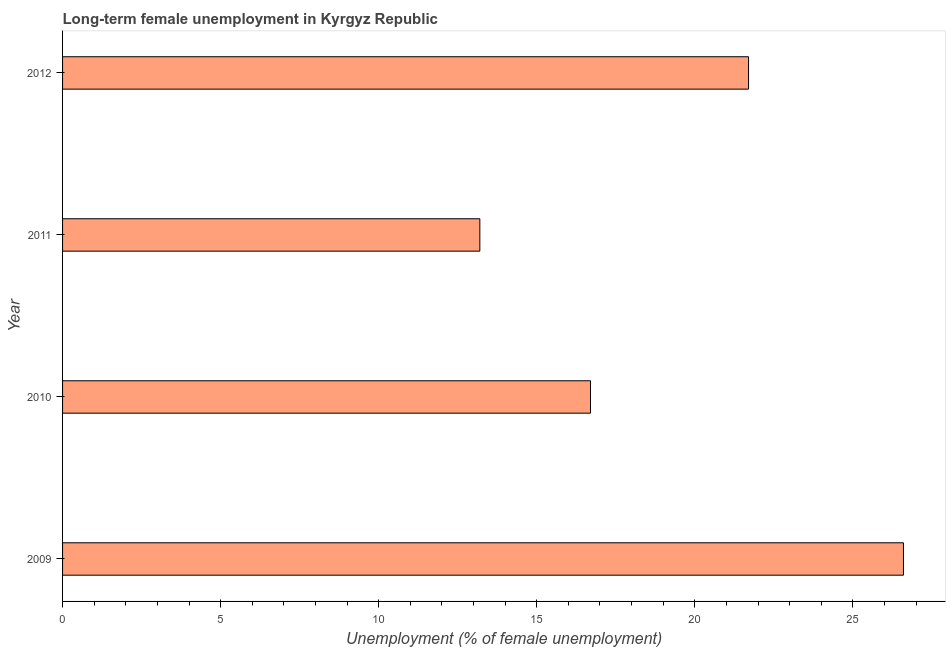Does the graph contain any zero values?
Give a very brief answer. No. What is the title of the graph?
Make the answer very short. Long-term female unemployment in Kyrgyz Republic. What is the label or title of the X-axis?
Make the answer very short. Unemployment (% of female unemployment). What is the long-term female unemployment in 2010?
Make the answer very short. 16.7. Across all years, what is the maximum long-term female unemployment?
Your answer should be very brief. 26.6. Across all years, what is the minimum long-term female unemployment?
Give a very brief answer. 13.2. In which year was the long-term female unemployment maximum?
Offer a very short reply. 2009. In which year was the long-term female unemployment minimum?
Your answer should be very brief. 2011. What is the sum of the long-term female unemployment?
Your answer should be compact. 78.2. What is the difference between the long-term female unemployment in 2009 and 2012?
Offer a terse response. 4.9. What is the average long-term female unemployment per year?
Provide a succinct answer. 19.55. What is the median long-term female unemployment?
Offer a terse response. 19.2. Do a majority of the years between 2010 and 2012 (inclusive) have long-term female unemployment greater than 24 %?
Provide a short and direct response. No. What is the ratio of the long-term female unemployment in 2009 to that in 2010?
Offer a terse response. 1.59. Is the difference between the long-term female unemployment in 2010 and 2012 greater than the difference between any two years?
Make the answer very short. No. What is the Unemployment (% of female unemployment) of 2009?
Offer a terse response. 26.6. What is the Unemployment (% of female unemployment) of 2010?
Your answer should be very brief. 16.7. What is the Unemployment (% of female unemployment) of 2011?
Give a very brief answer. 13.2. What is the Unemployment (% of female unemployment) of 2012?
Offer a very short reply. 21.7. What is the difference between the Unemployment (% of female unemployment) in 2009 and 2010?
Provide a short and direct response. 9.9. What is the difference between the Unemployment (% of female unemployment) in 2009 and 2012?
Offer a very short reply. 4.9. What is the difference between the Unemployment (% of female unemployment) in 2010 and 2012?
Keep it short and to the point. -5. What is the difference between the Unemployment (% of female unemployment) in 2011 and 2012?
Offer a terse response. -8.5. What is the ratio of the Unemployment (% of female unemployment) in 2009 to that in 2010?
Provide a succinct answer. 1.59. What is the ratio of the Unemployment (% of female unemployment) in 2009 to that in 2011?
Your response must be concise. 2.02. What is the ratio of the Unemployment (% of female unemployment) in 2009 to that in 2012?
Offer a terse response. 1.23. What is the ratio of the Unemployment (% of female unemployment) in 2010 to that in 2011?
Offer a very short reply. 1.26. What is the ratio of the Unemployment (% of female unemployment) in 2010 to that in 2012?
Give a very brief answer. 0.77. What is the ratio of the Unemployment (% of female unemployment) in 2011 to that in 2012?
Give a very brief answer. 0.61. 